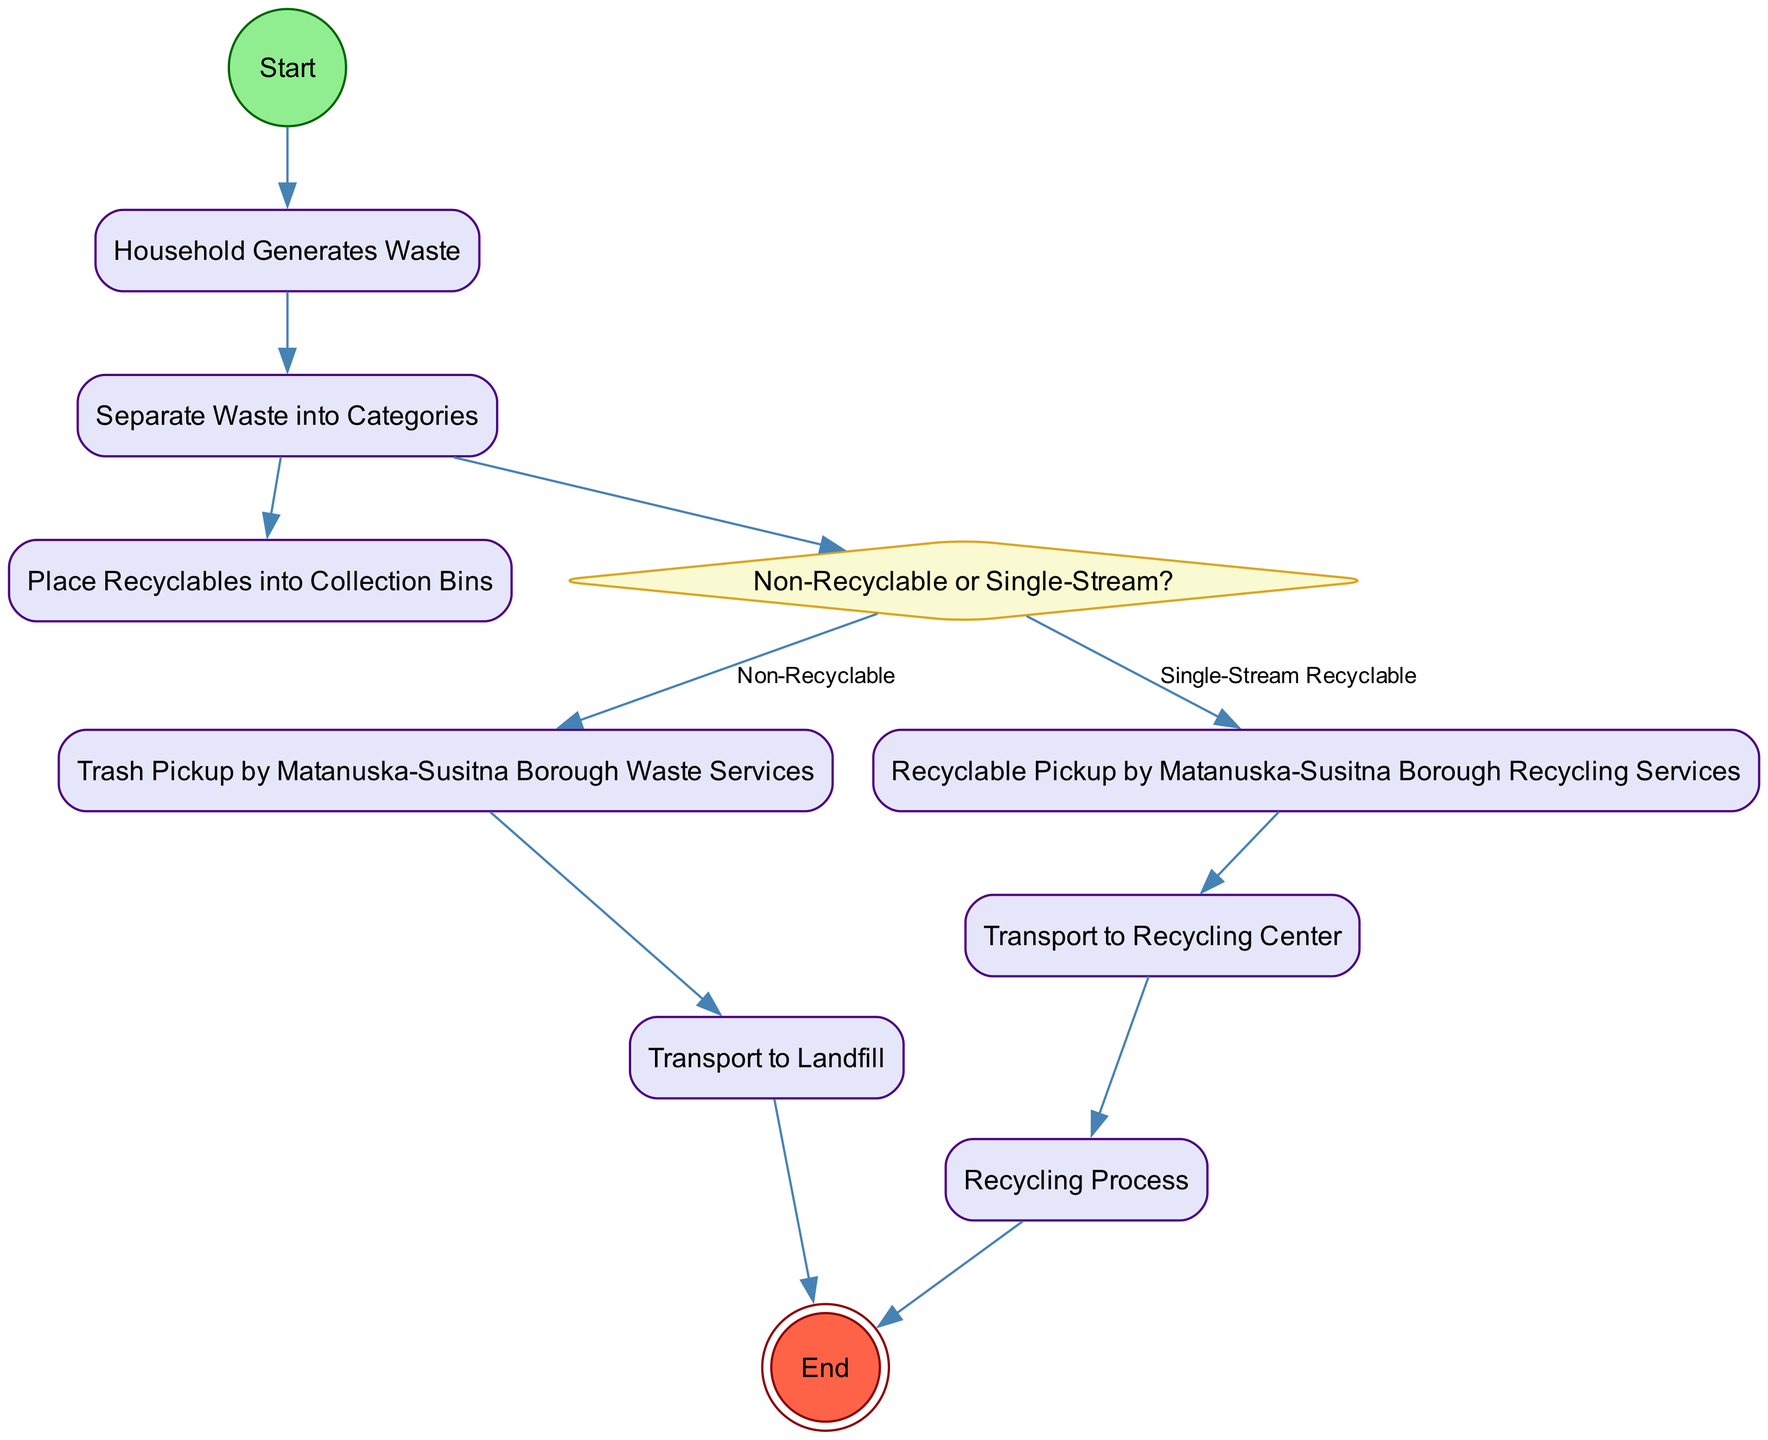What is the starting point of the diagram? The starting point is indicated by the node labeled "Start". It is the entry point of the activity diagram where the process begins.
Answer: Start How many activities are there in total? The diagram contains seven activity nodes: Household Generates Waste, Separate Waste into Categories, Place Recyclables into Collection Bins, Trash Pickup by Matanuska-Susitna Borough Waste Services, Recyclable Pickup by Matanuska-Susitna Borough Recycling Services, Transport to Landfill, and Transport to Recycling Center. Counting them gives us a total of seven activities.
Answer: 7 What happens after separating waste? After separating waste, the next step involves placing recyclables into collection bins and determining whether the waste is non-recyclable or single-stream. This represents a branching decision point in the process.
Answer: Place Recyclables into Collection Bins and Non-Recyclable or Single-Stream? What is the purpose of the decision node "Non-Recyclable or Single-Stream?" This decision node serves to categorize the waste into two pathways: if the waste is non-recyclable, it directs to Trash Pickup, whereas if it is single-stream recyclable, it directs to Recyclable Pickup. This decision is crucial for determining the next steps based on the type of waste.
Answer: Categorize waste What occurs at the end of the recycling process? After the recycling process is completed, the diagram indicates that the process concludes at the "End" node, marking the completion of the waste management and recycling workflow.
Answer: End 